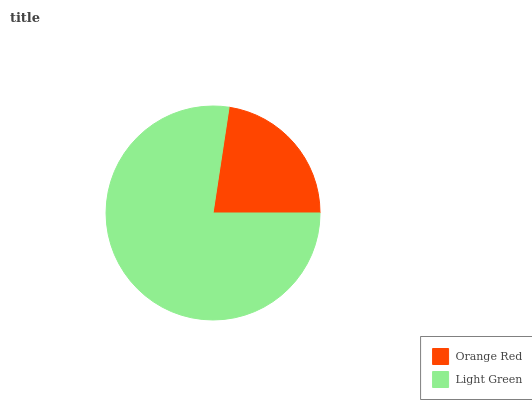Is Orange Red the minimum?
Answer yes or no. Yes. Is Light Green the maximum?
Answer yes or no. Yes. Is Light Green the minimum?
Answer yes or no. No. Is Light Green greater than Orange Red?
Answer yes or no. Yes. Is Orange Red less than Light Green?
Answer yes or no. Yes. Is Orange Red greater than Light Green?
Answer yes or no. No. Is Light Green less than Orange Red?
Answer yes or no. No. Is Light Green the high median?
Answer yes or no. Yes. Is Orange Red the low median?
Answer yes or no. Yes. Is Orange Red the high median?
Answer yes or no. No. Is Light Green the low median?
Answer yes or no. No. 